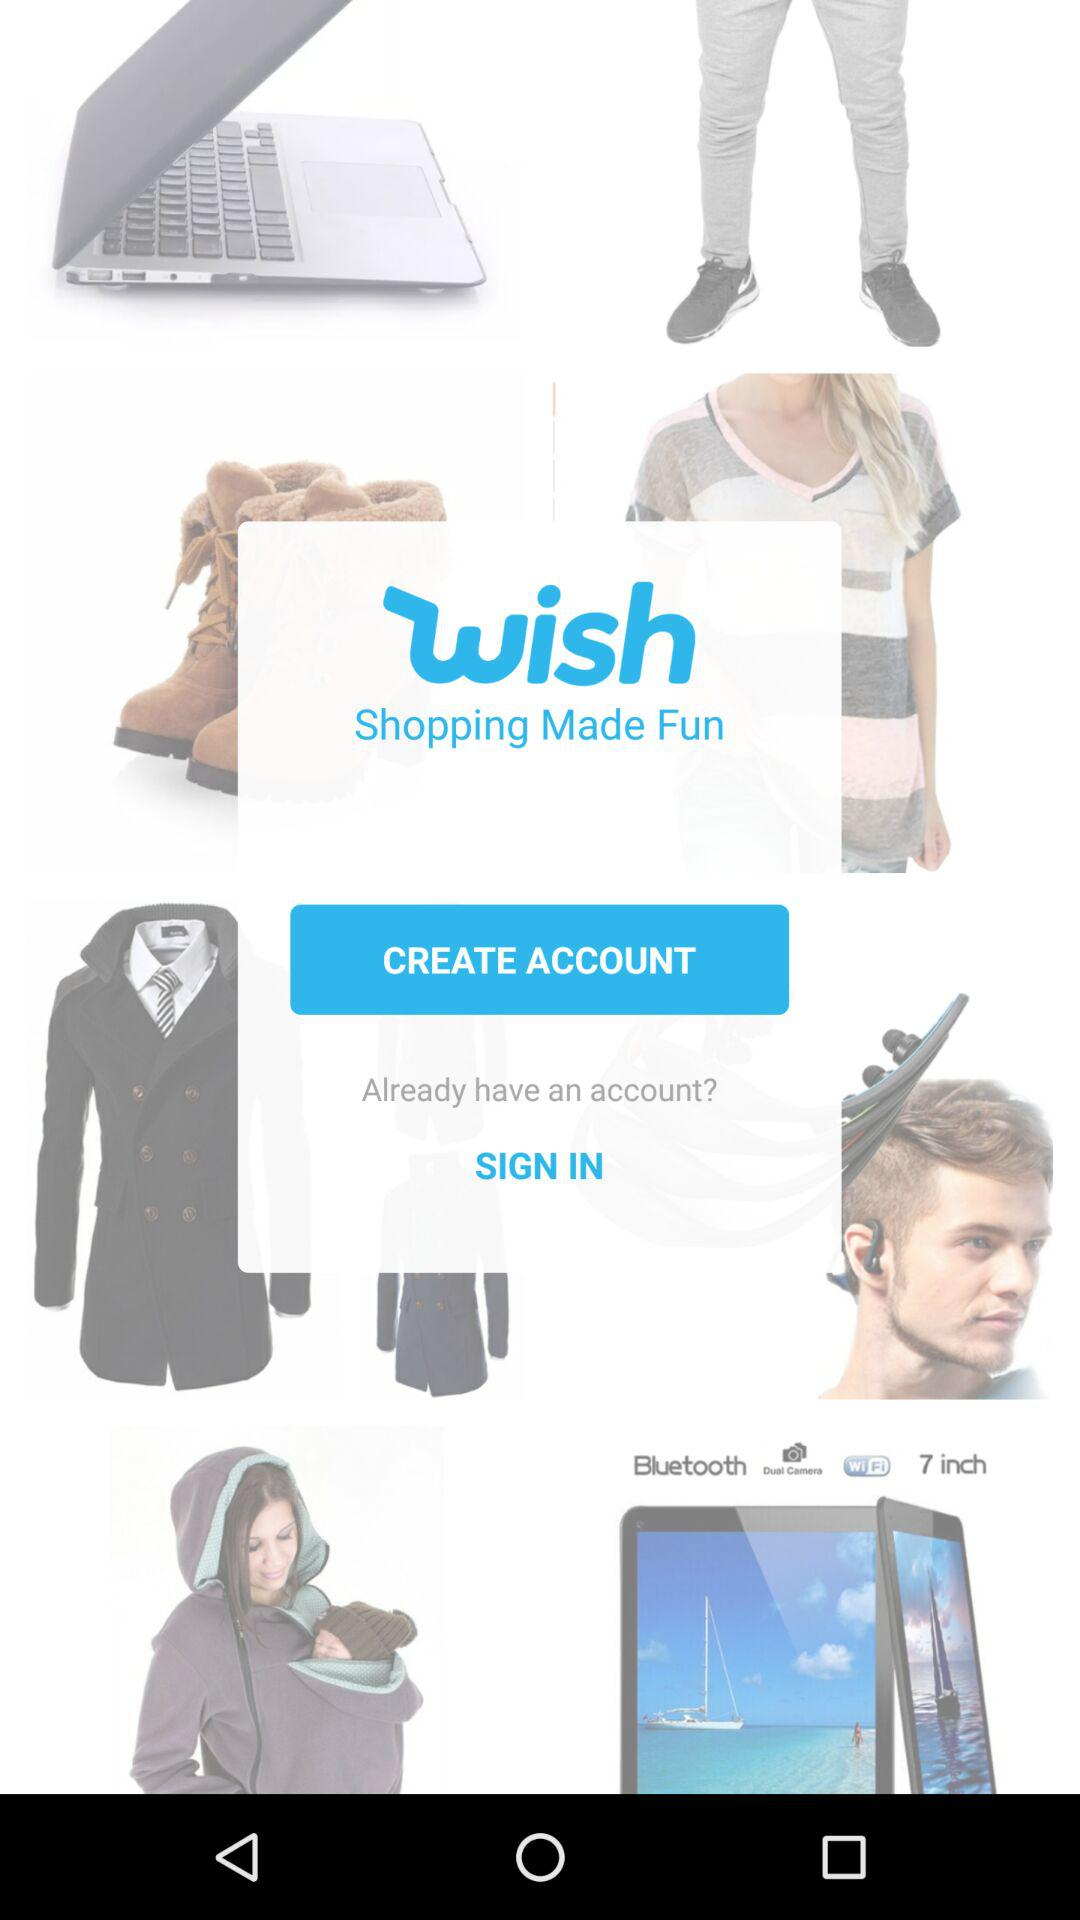How long does it take to create an account?
When the provided information is insufficient, respond with <no answer>. <no answer> 